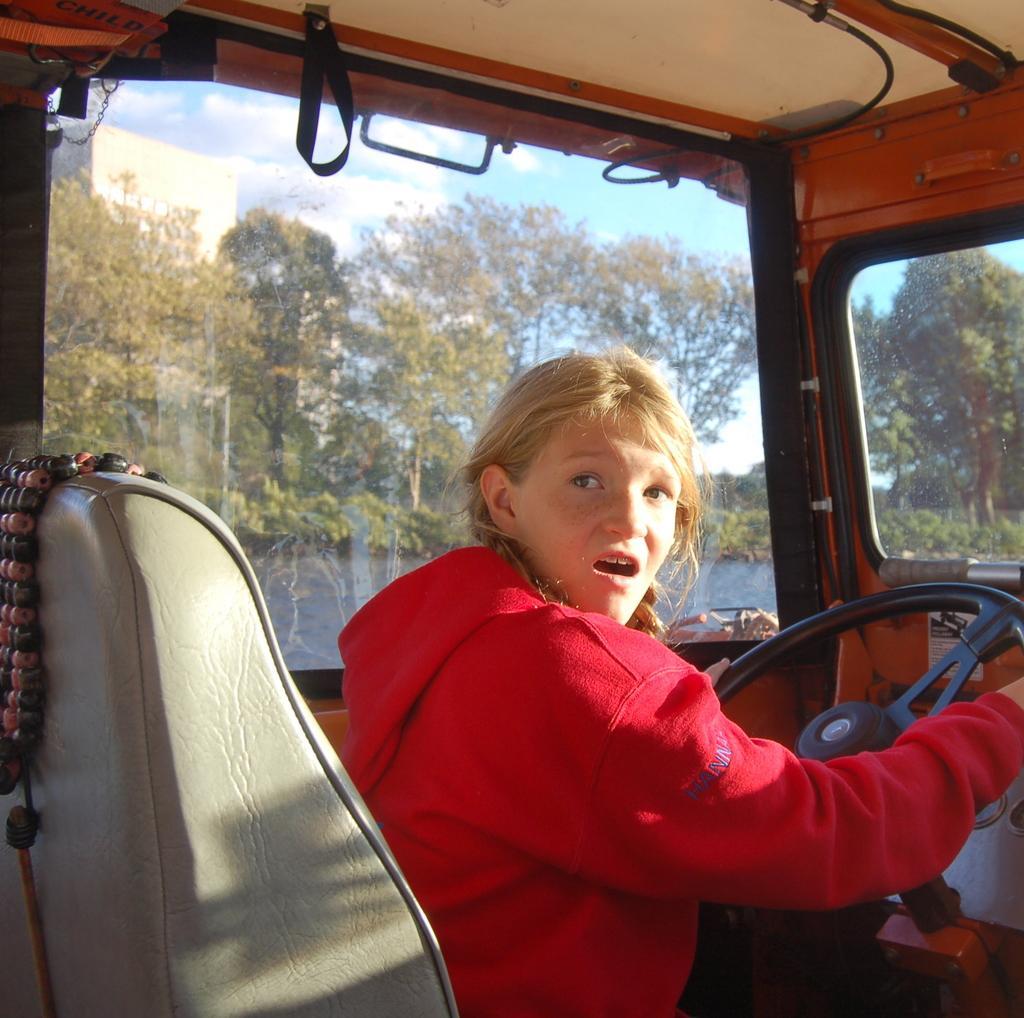In one or two sentences, can you explain what this image depicts? In this picture I can see there is a girl driving a truck and she is looking at the right side and there is a glass window and there are trees and the sky is clear. 